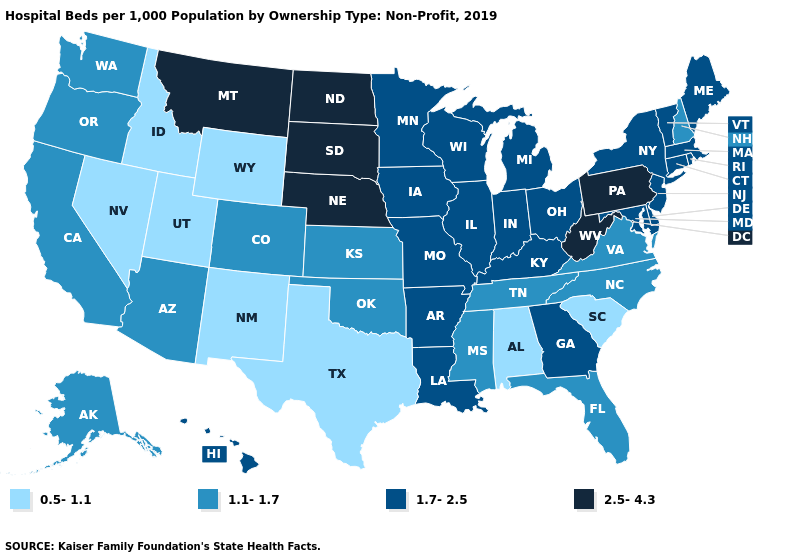Which states have the lowest value in the Northeast?
Concise answer only. New Hampshire. Does Wyoming have a lower value than Texas?
Answer briefly. No. Does Indiana have the lowest value in the MidWest?
Quick response, please. No. Does Delaware have a lower value than Louisiana?
Concise answer only. No. Name the states that have a value in the range 1.1-1.7?
Concise answer only. Alaska, Arizona, California, Colorado, Florida, Kansas, Mississippi, New Hampshire, North Carolina, Oklahoma, Oregon, Tennessee, Virginia, Washington. Name the states that have a value in the range 0.5-1.1?
Answer briefly. Alabama, Idaho, Nevada, New Mexico, South Carolina, Texas, Utah, Wyoming. Name the states that have a value in the range 1.7-2.5?
Concise answer only. Arkansas, Connecticut, Delaware, Georgia, Hawaii, Illinois, Indiana, Iowa, Kentucky, Louisiana, Maine, Maryland, Massachusetts, Michigan, Minnesota, Missouri, New Jersey, New York, Ohio, Rhode Island, Vermont, Wisconsin. What is the lowest value in the Northeast?
Be succinct. 1.1-1.7. Which states hav the highest value in the South?
Write a very short answer. West Virginia. Which states hav the highest value in the MidWest?
Short answer required. Nebraska, North Dakota, South Dakota. Does the first symbol in the legend represent the smallest category?
Write a very short answer. Yes. What is the highest value in states that border Massachusetts?
Quick response, please. 1.7-2.5. What is the highest value in the West ?
Keep it brief. 2.5-4.3. What is the highest value in the MidWest ?
Be succinct. 2.5-4.3. Name the states that have a value in the range 1.1-1.7?
Concise answer only. Alaska, Arizona, California, Colorado, Florida, Kansas, Mississippi, New Hampshire, North Carolina, Oklahoma, Oregon, Tennessee, Virginia, Washington. 